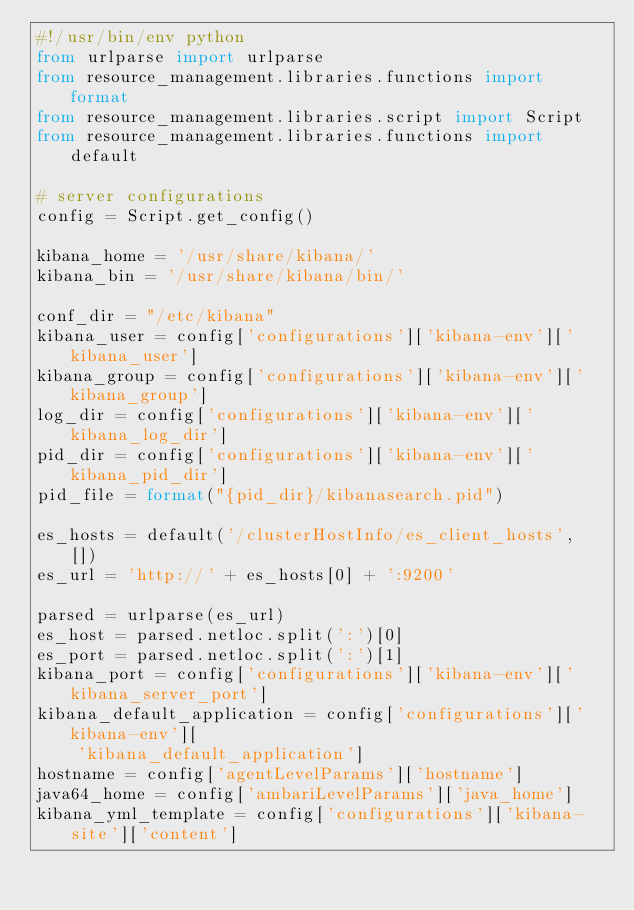<code> <loc_0><loc_0><loc_500><loc_500><_Python_>#!/usr/bin/env python
from urlparse import urlparse
from resource_management.libraries.functions import format
from resource_management.libraries.script import Script
from resource_management.libraries.functions import default

# server configurations
config = Script.get_config()

kibana_home = '/usr/share/kibana/'
kibana_bin = '/usr/share/kibana/bin/'

conf_dir = "/etc/kibana"
kibana_user = config['configurations']['kibana-env']['kibana_user']
kibana_group = config['configurations']['kibana-env']['kibana_group']
log_dir = config['configurations']['kibana-env']['kibana_log_dir']
pid_dir = config['configurations']['kibana-env']['kibana_pid_dir']
pid_file = format("{pid_dir}/kibanasearch.pid")

es_hosts = default('/clusterHostInfo/es_client_hosts', [])
es_url = 'http://' + es_hosts[0] + ':9200'

parsed = urlparse(es_url)
es_host = parsed.netloc.split(':')[0]
es_port = parsed.netloc.split(':')[1]
kibana_port = config['configurations']['kibana-env']['kibana_server_port']
kibana_default_application = config['configurations']['kibana-env'][
    'kibana_default_application']
hostname = config['agentLevelParams']['hostname']
java64_home = config['ambariLevelParams']['java_home']
kibana_yml_template = config['configurations']['kibana-site']['content']
</code> 